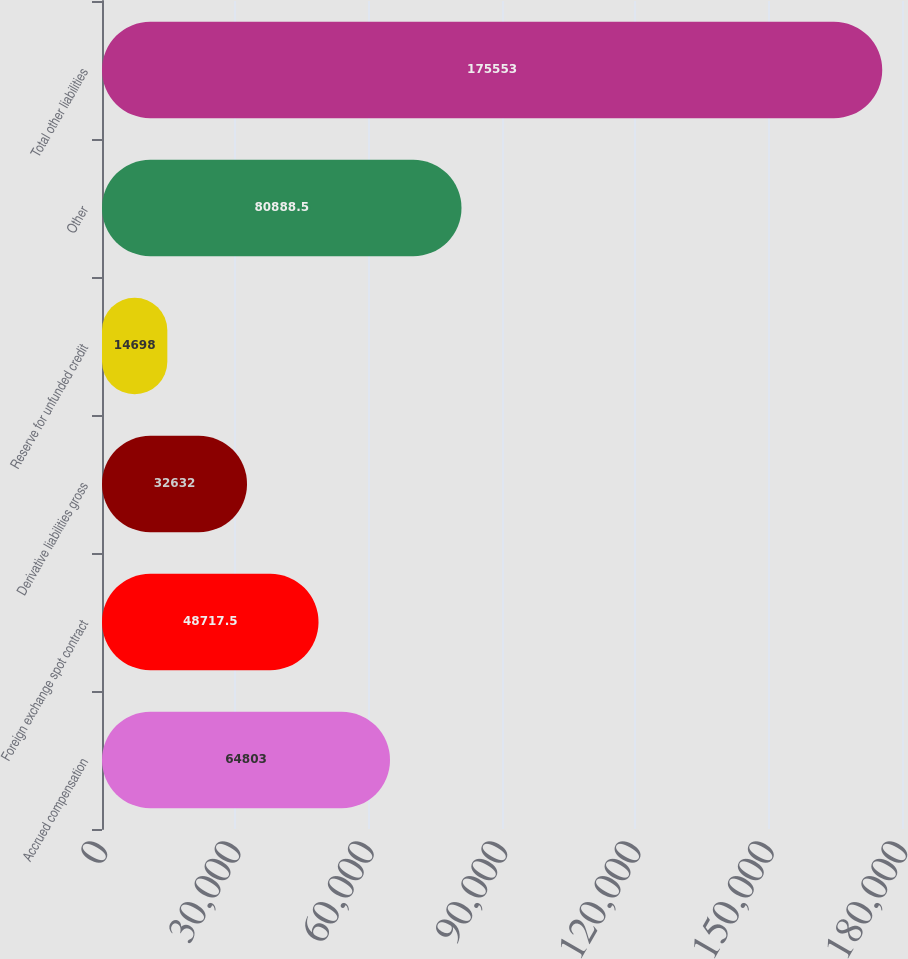Convert chart to OTSL. <chart><loc_0><loc_0><loc_500><loc_500><bar_chart><fcel>Accrued compensation<fcel>Foreign exchange spot contract<fcel>Derivative liabilities gross<fcel>Reserve for unfunded credit<fcel>Other<fcel>Total other liabilities<nl><fcel>64803<fcel>48717.5<fcel>32632<fcel>14698<fcel>80888.5<fcel>175553<nl></chart> 